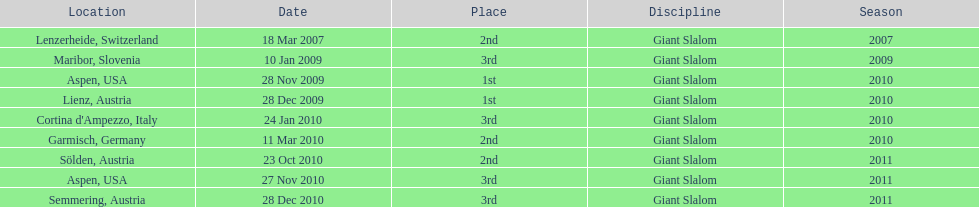Would you be able to parse every entry in this table? {'header': ['Location', 'Date', 'Place', 'Discipline', 'Season'], 'rows': [['Lenzerheide, Switzerland', '18 Mar 2007', '2nd', 'Giant Slalom', '2007'], ['Maribor, Slovenia', '10 Jan 2009', '3rd', 'Giant Slalom', '2009'], ['Aspen, USA', '28 Nov 2009', '1st', 'Giant Slalom', '2010'], ['Lienz, Austria', '28 Dec 2009', '1st', 'Giant Slalom', '2010'], ["Cortina d'Ampezzo, Italy", '24 Jan 2010', '3rd', 'Giant Slalom', '2010'], ['Garmisch, Germany', '11 Mar 2010', '2nd', 'Giant Slalom', '2010'], ['Sölden, Austria', '23 Oct 2010', '2nd', 'Giant Slalom', '2011'], ['Aspen, USA', '27 Nov 2010', '3rd', 'Giant Slalom', '2011'], ['Semmering, Austria', '28 Dec 2010', '3rd', 'Giant Slalom', '2011']]} Where was her first win? Aspen, USA. 